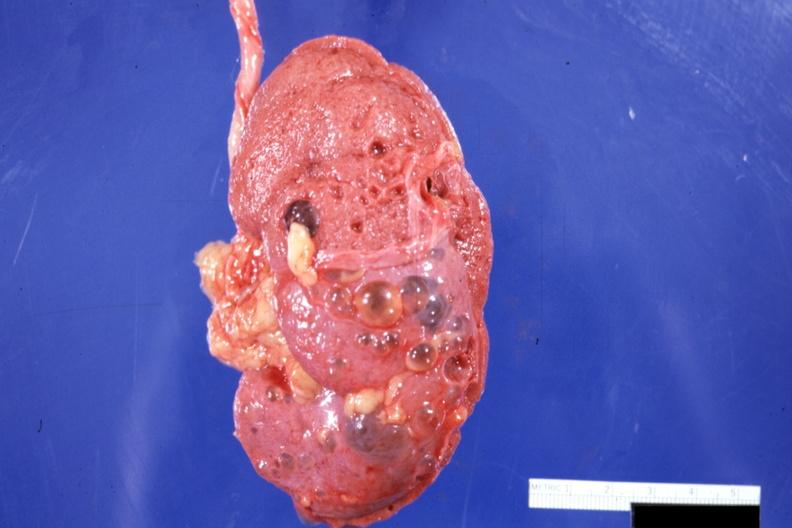s kidney present?
Answer the question using a single word or phrase. Yes 